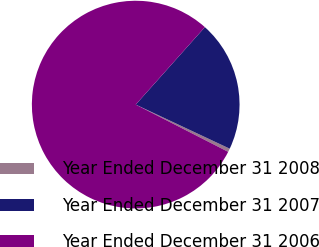Convert chart to OTSL. <chart><loc_0><loc_0><loc_500><loc_500><pie_chart><fcel>Year Ended December 31 2008<fcel>Year Ended December 31 2007<fcel>Year Ended December 31 2006<nl><fcel>0.54%<fcel>20.38%<fcel>79.08%<nl></chart> 